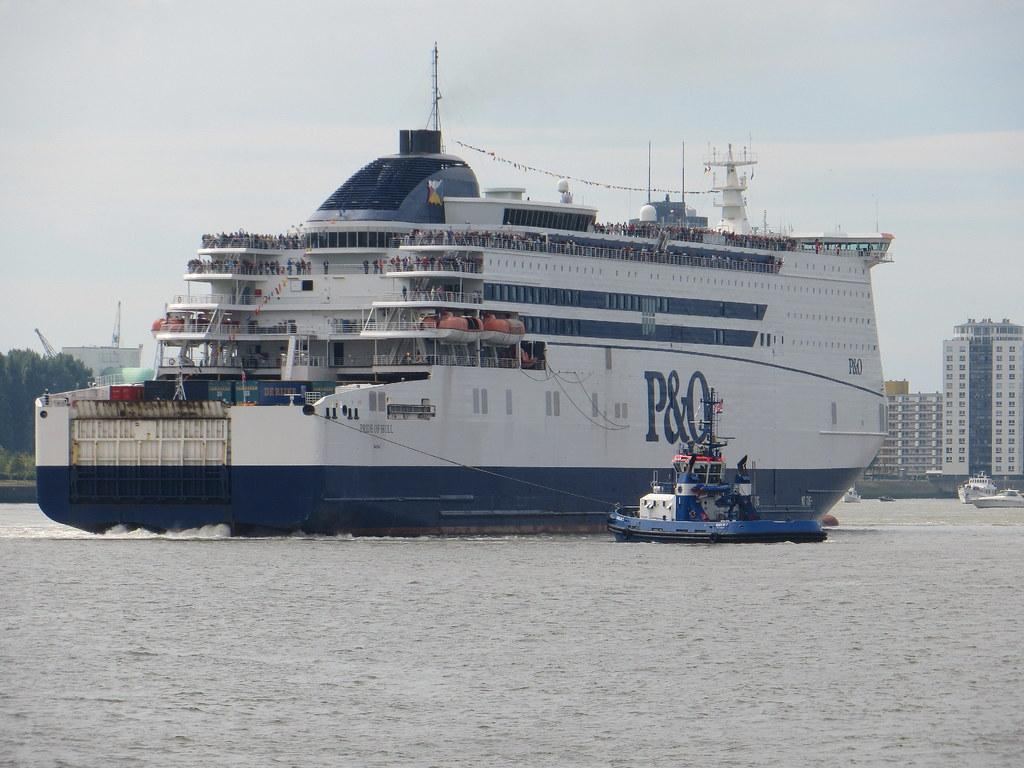<image>
Present a compact description of the photo's key features. a boat with the large letter P on it 